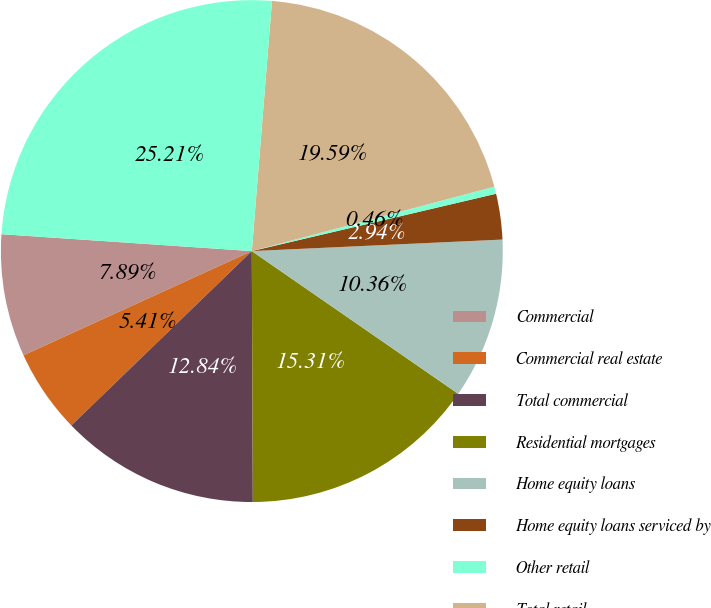Convert chart to OTSL. <chart><loc_0><loc_0><loc_500><loc_500><pie_chart><fcel>Commercial<fcel>Commercial real estate<fcel>Total commercial<fcel>Residential mortgages<fcel>Home equity loans<fcel>Home equity loans serviced by<fcel>Other retail<fcel>Total retail<fcel>Total<nl><fcel>7.89%<fcel>5.41%<fcel>12.84%<fcel>15.31%<fcel>10.36%<fcel>2.94%<fcel>0.46%<fcel>19.59%<fcel>25.21%<nl></chart> 